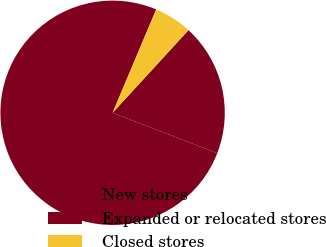<chart> <loc_0><loc_0><loc_500><loc_500><pie_chart><fcel>New stores<fcel>Expanded or relocated stores<fcel>Closed stores<nl><fcel>75.49%<fcel>19.04%<fcel>5.47%<nl></chart> 